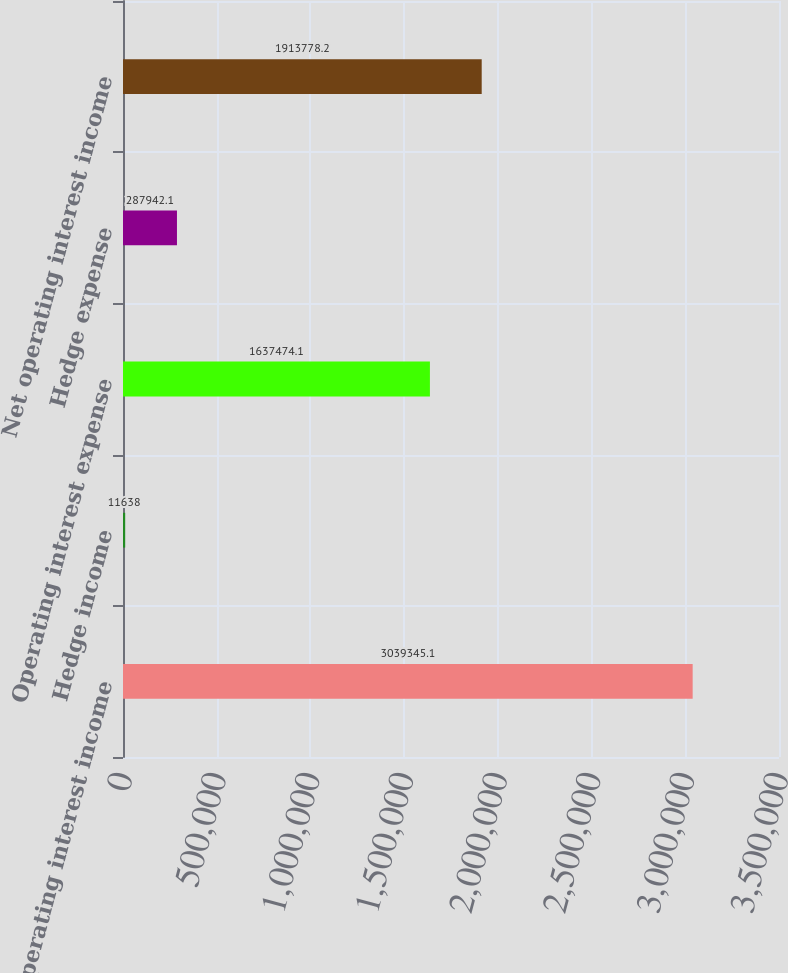Convert chart to OTSL. <chart><loc_0><loc_0><loc_500><loc_500><bar_chart><fcel>Operating interest income<fcel>Hedge income<fcel>Operating interest expense<fcel>Hedge expense<fcel>Net operating interest income<nl><fcel>3.03935e+06<fcel>11638<fcel>1.63747e+06<fcel>287942<fcel>1.91378e+06<nl></chart> 